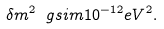Convert formula to latex. <formula><loc_0><loc_0><loc_500><loc_500>\delta m ^ { 2 } \ g s i m 1 0 ^ { - 1 2 } e V ^ { 2 } .</formula> 